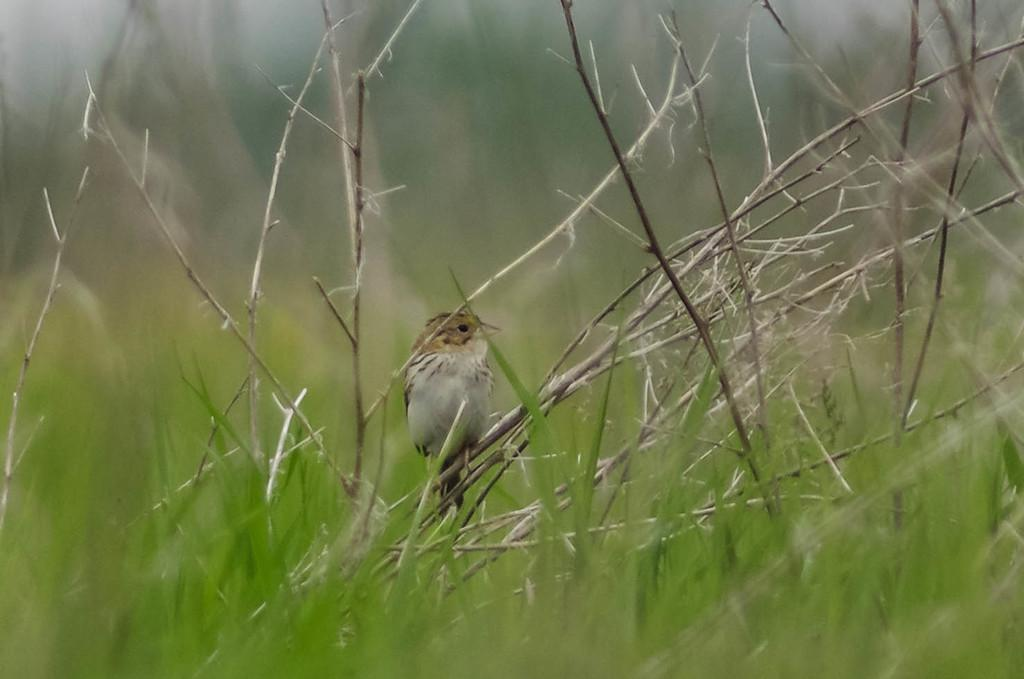What type of animal can be seen in the image? There is a bird in the image. Where is the bird located? The bird is sitting on a plant. What type of vegetation is visible in the image? There is grass visible in the image. How many eggs can be seen in the image? There are no eggs present in the image. What level of difficulty is the plant on in the image? The image does not provide information about the difficulty level of the plant. 